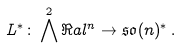<formula> <loc_0><loc_0><loc_500><loc_500>L ^ { * } \colon \bigwedge ^ { 2 } \Re a l ^ { n } \rightarrow \mathfrak { s o } ( n ) ^ { * } \, .</formula> 